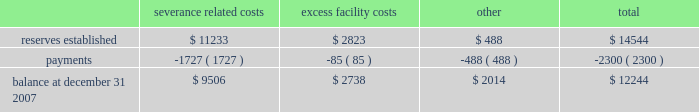Lkq corporation and subsidiaries notes to consolidated financial statements ( continued ) note 8 .
Restructuring and integration costs ( continued ) levels and the closure of excess facilities .
To the extent these restructuring activities are associated with keystone operations , they are being accounted for in accordance with eitf issue no .
95-3 , 2018 2018recognition of liabilities in connection with a purchase business combination . 2019 2019 restructuring activities associated with our existing operations are being accounted for in accordance with sfas no .
146 , 2018 2018accounting for costs associated with exit or disposal activities . 2019 2019 in connection with the keystone restructuring activities , as part of the cost of the acquisition , we established reserves as detailed below .
In accordance with eitf issue no .
95-3 , we intend to finalize our restructuring plans no later than one year from the date of our acquisition of keystone .
Upon finalization of restructuring plans or settlement of obligations for less than the expected amount , any excess reserves will be reversed with a corresponding decrease in goodwill .
Accrued acquisition expenses are included in other accrued expenses in the accompanying consolidated balance sheets .
The changes in accrued acquisition expenses directly related to the keystone acquisition during 2007 are as follows ( in thousands ) : severance excess related costs facility costs other total .
Restructuring and integration costs associated with our existing operations are included in restructuring expenses on the accompanying consolidated statements of income .
Note 9 .
Related party transactions we sublease a portion of our corporate office space to an entity owned by the son of one of our principal stockholders for a pro rata percentage of the rent that we are charged .
The total amounts received from this entity were approximately $ 54000 , $ 70000 and $ 49000 during the years ended december 31 , 2007 , 2006 and 2005 , respectively .
We also paid this entity approximately $ 0.4 million during 2007 for consulting fees incurred in connection with our new secured debt facility .
A corporation owned by our chairman of the board , who is also one of our principal stockholders , owns private aircraft that we use from time to time for business trips .
We reimburse this corporation for out-of-pocket and other related flight expenses , as well as for other direct expenses incurred .
The total amounts paid to this corporation were approximately $ 102000 , $ 6400 and $ 122000 during each of the years ended december 31 , 2007 , 2006 and 2005 , respectively .
In connection with the acquisitions of several businesses , we entered into agreements with several sellers of those businesses , who became stockholders as a result of those acquisitions , for the lease of certain properties used in our operations .
Typical lease terms include an initial term of five years , with three five-year renewal options and purchase options at various times throughout the lease periods .
We also maintain the right of first refusal concerning the sale of the leased property .
Lease payments to a principal stockholder who became an officer of the company after the acquisition of his business were approximately $ 0.8 million during each of the years ended december 31 , 2007 , 2006 and 2005 , respectively. .
Based on the review of the keystone acquisition expenses what was the percent of the total reserves established associated with severance related costs? 
Computations: (11233 / 14544)
Answer: 0.77235. 